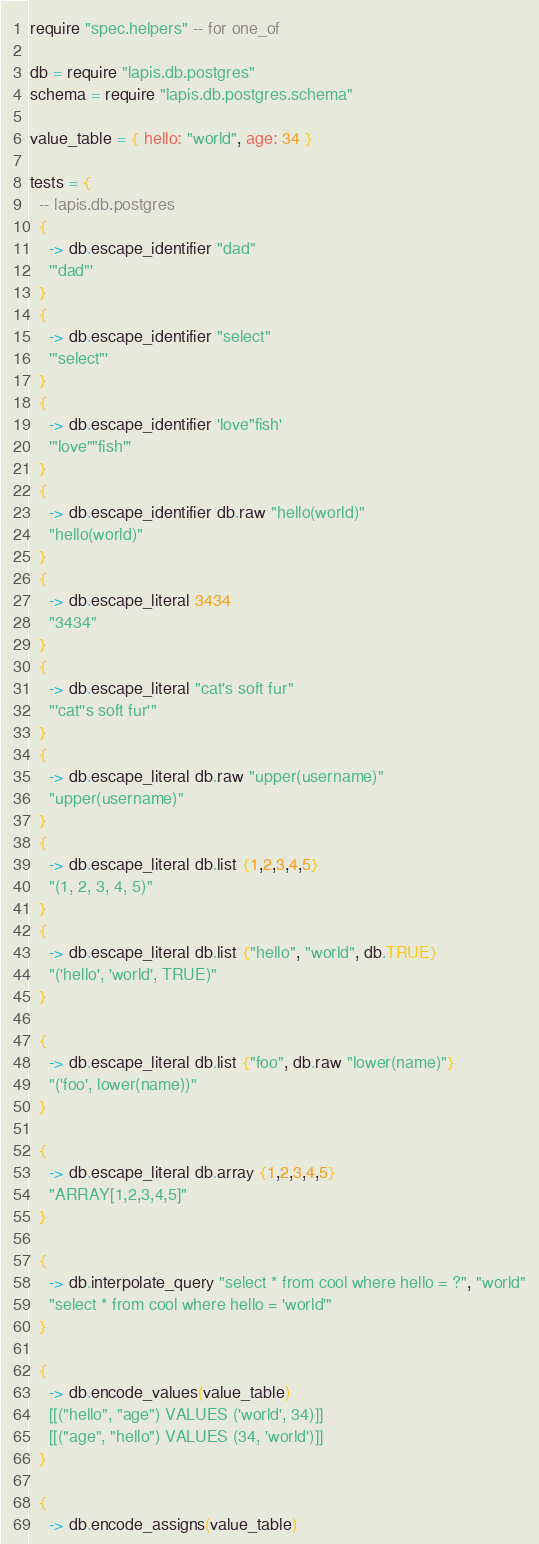<code> <loc_0><loc_0><loc_500><loc_500><_MoonScript_>require "spec.helpers" -- for one_of

db = require "lapis.db.postgres"
schema = require "lapis.db.postgres.schema"

value_table = { hello: "world", age: 34 }

tests = {
  -- lapis.db.postgres
  {
    -> db.escape_identifier "dad"
    '"dad"'
  }
  {
    -> db.escape_identifier "select"
    '"select"'
  }
  {
    -> db.escape_identifier 'love"fish'
    '"love""fish"'
  }
  {
    -> db.escape_identifier db.raw "hello(world)"
    "hello(world)"
  }
  {
    -> db.escape_literal 3434
    "3434"
  }
  {
    -> db.escape_literal "cat's soft fur"
    "'cat''s soft fur'"
  }
  {
    -> db.escape_literal db.raw "upper(username)"
    "upper(username)"
  }
  {
    -> db.escape_literal db.list {1,2,3,4,5}
    "(1, 2, 3, 4, 5)"
  }
  {
    -> db.escape_literal db.list {"hello", "world", db.TRUE}
    "('hello', 'world', TRUE)"
  }

  {
    -> db.escape_literal db.list {"foo", db.raw "lower(name)"}
    "('foo', lower(name))"
  }

  {
    -> db.escape_literal db.array {1,2,3,4,5}
    "ARRAY[1,2,3,4,5]"
  }

  {
    -> db.interpolate_query "select * from cool where hello = ?", "world"
    "select * from cool where hello = 'world'"
  }

  {
    -> db.encode_values(value_table)
    [[("hello", "age") VALUES ('world', 34)]]
    [[("age", "hello") VALUES (34, 'world')]]
  }

  {
    -> db.encode_assigns(value_table)</code> 